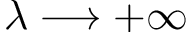Convert formula to latex. <formula><loc_0><loc_0><loc_500><loc_500>\lambda \longrightarrow + \infty</formula> 